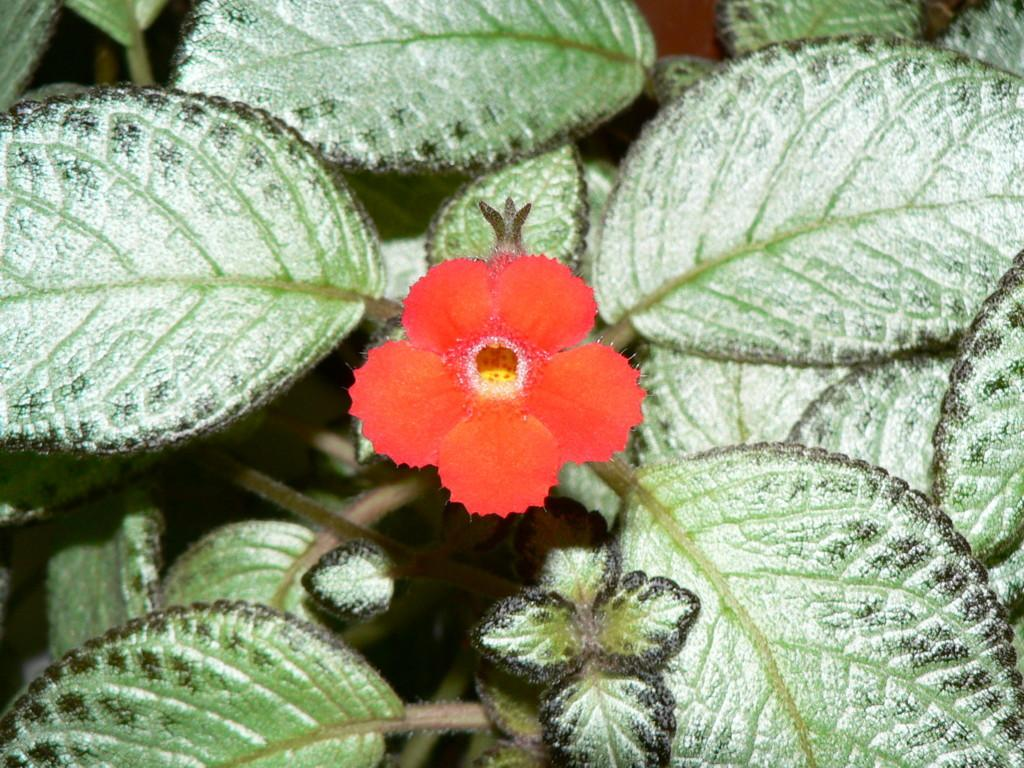What type of plant can be seen in the image? There is a flower in the image. What part of the plant is visible in the image? There are green leaves in the image. How many houses are visible in the image? There are no houses present in the image; it only features a flower and green leaves. 